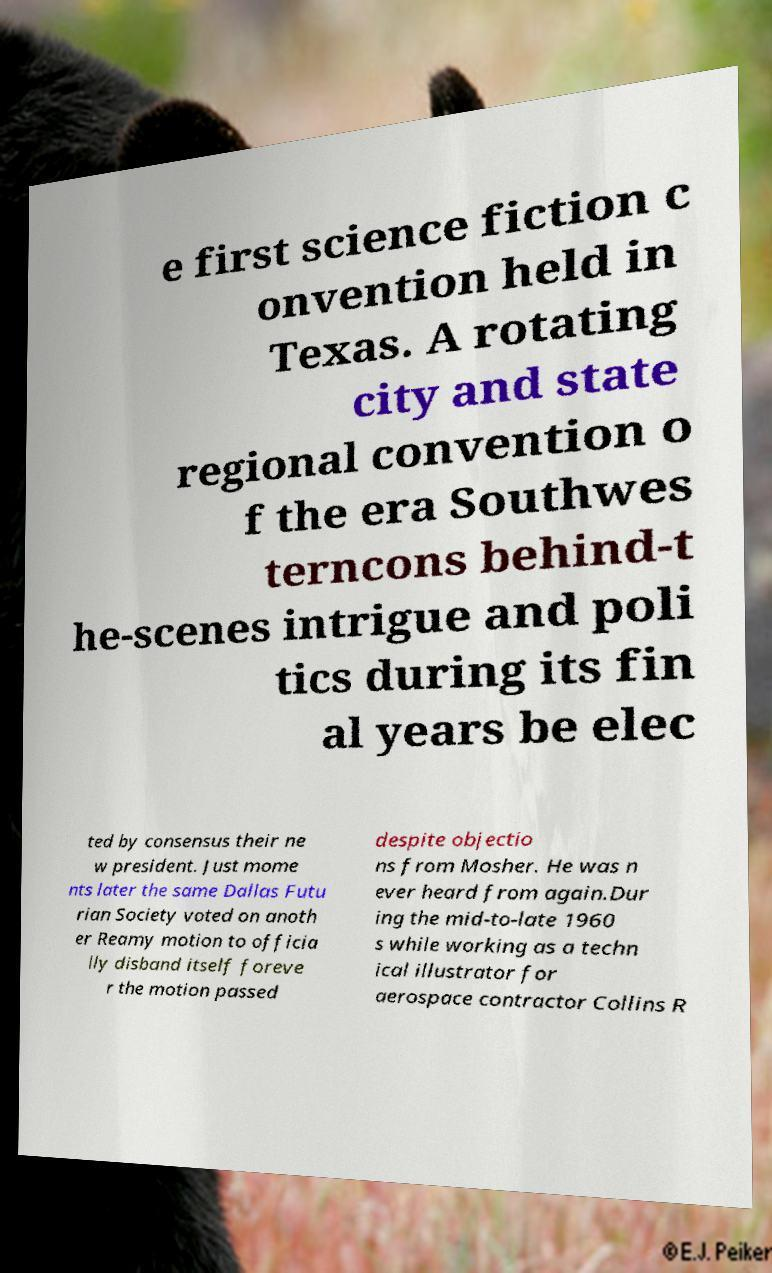For documentation purposes, I need the text within this image transcribed. Could you provide that? e first science fiction c onvention held in Texas. A rotating city and state regional convention o f the era Southwes terncons behind-t he-scenes intrigue and poli tics during its fin al years be elec ted by consensus their ne w president. Just mome nts later the same Dallas Futu rian Society voted on anoth er Reamy motion to officia lly disband itself foreve r the motion passed despite objectio ns from Mosher. He was n ever heard from again.Dur ing the mid-to-late 1960 s while working as a techn ical illustrator for aerospace contractor Collins R 